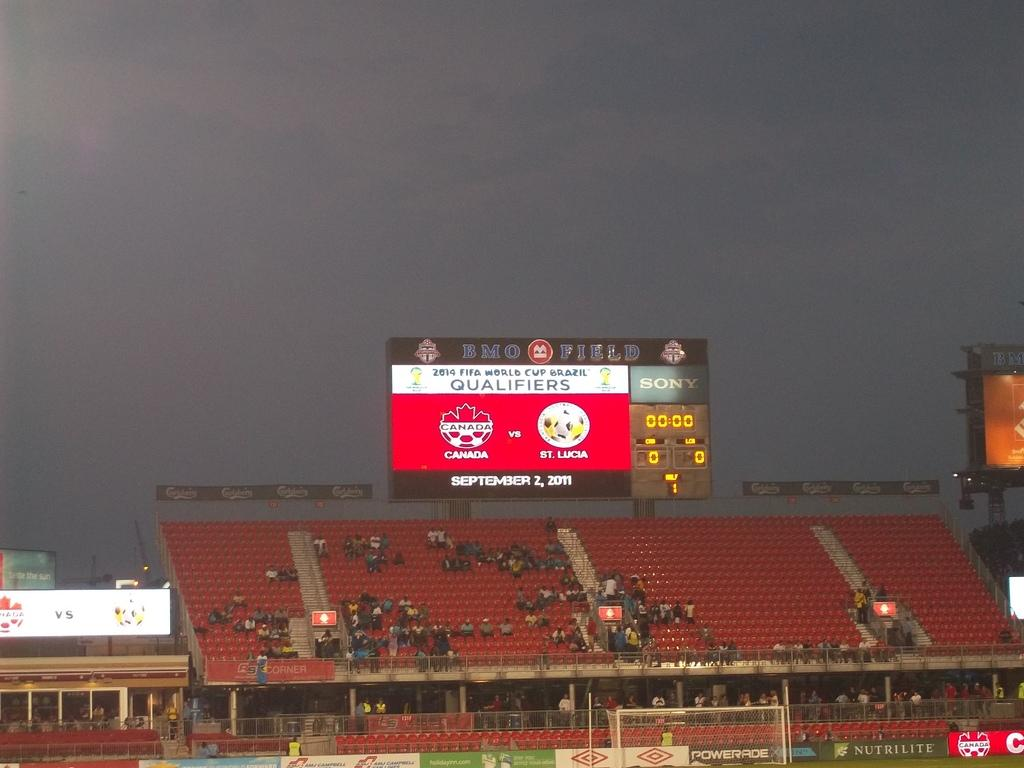<image>
Render a clear and concise summary of the photo. The scoreboard of a soccer match between Canada and St. Lucia shows a score of 0-0. 